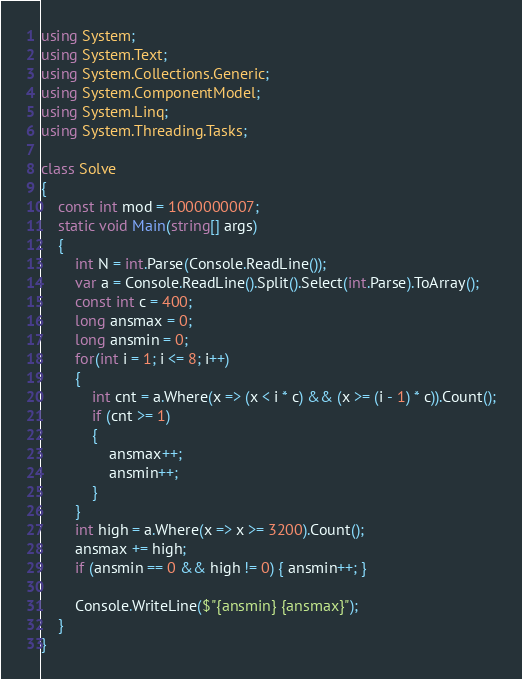<code> <loc_0><loc_0><loc_500><loc_500><_C#_>using System;
using System.Text;
using System.Collections.Generic;
using System.ComponentModel;
using System.Linq;
using System.Threading.Tasks;

class Solve
{
	const int mod = 1000000007;
	static void Main(string[] args)
	{
		int N = int.Parse(Console.ReadLine());
		var a = Console.ReadLine().Split().Select(int.Parse).ToArray();
		const int c = 400;
		long ansmax = 0;
		long ansmin = 0;
        for(int i = 1; i <= 8; i++)
		{
			int cnt = a.Where(x => (x < i * c) && (x >= (i - 1) * c)).Count();
			if (cnt >= 1)
			{
				ansmax++;
				ansmin++;
			}
		}
		int high = a.Where(x => x >= 3200).Count();
		ansmax += high;
		if (ansmin == 0 && high != 0) { ansmin++; }

		Console.WriteLine($"{ansmin} {ansmax}");
	}
}
</code> 